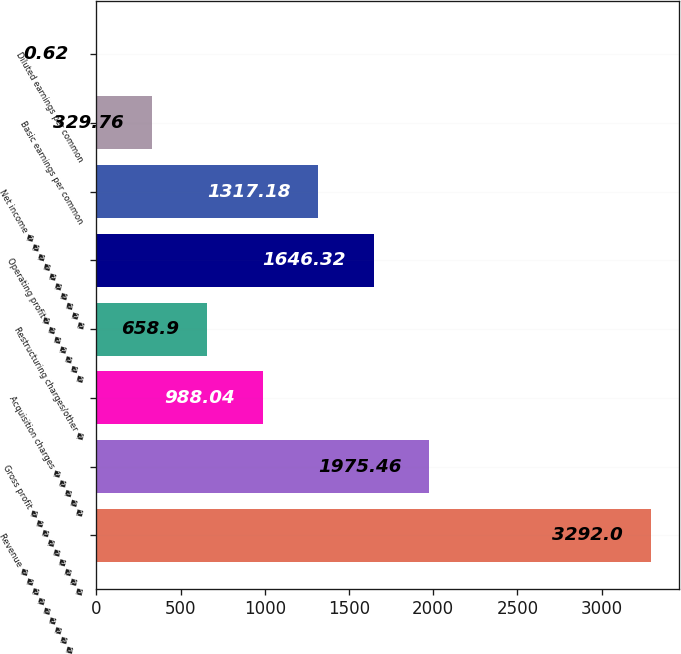Convert chart to OTSL. <chart><loc_0><loc_0><loc_500><loc_500><bar_chart><fcel>Revenue � � � � � � � � � � �<fcel>Gross profit � � � � � � � � �<fcel>Acquisition charges � � � � �<fcel>Restructuring charges/other �<fcel>Operating profit� � � � � � �<fcel>Net income � � � � � � � � � �<fcel>Basic earnings per common<fcel>Diluted earnings per common<nl><fcel>3292<fcel>1975.46<fcel>988.04<fcel>658.9<fcel>1646.32<fcel>1317.18<fcel>329.76<fcel>0.62<nl></chart> 